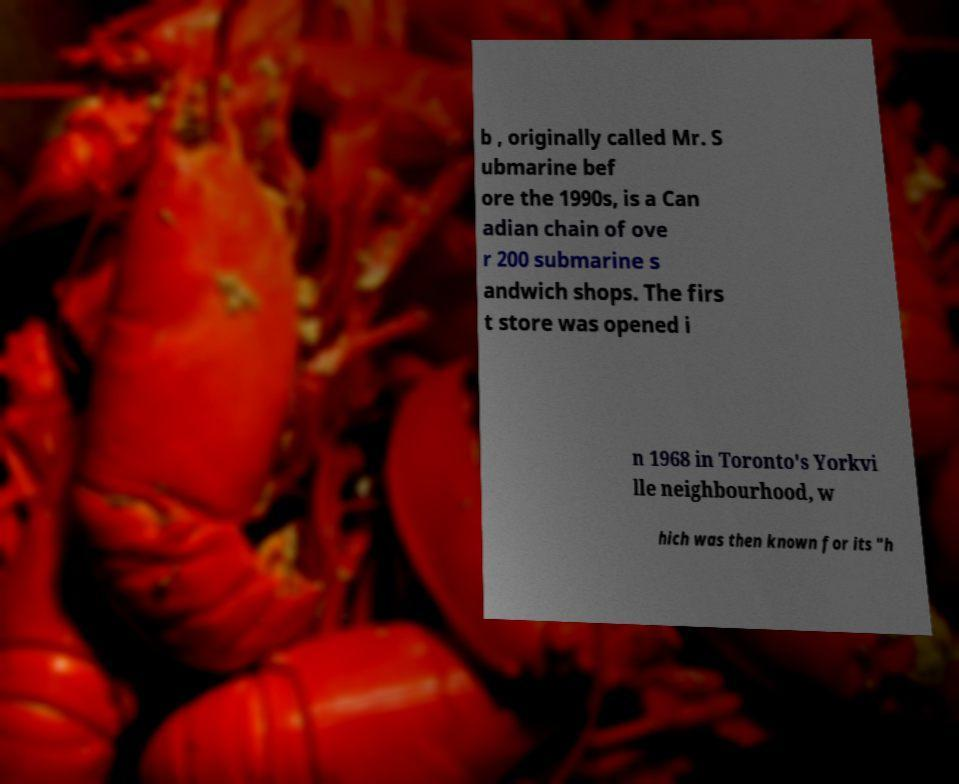For documentation purposes, I need the text within this image transcribed. Could you provide that? b , originally called Mr. S ubmarine bef ore the 1990s, is a Can adian chain of ove r 200 submarine s andwich shops. The firs t store was opened i n 1968 in Toronto's Yorkvi lle neighbourhood, w hich was then known for its "h 